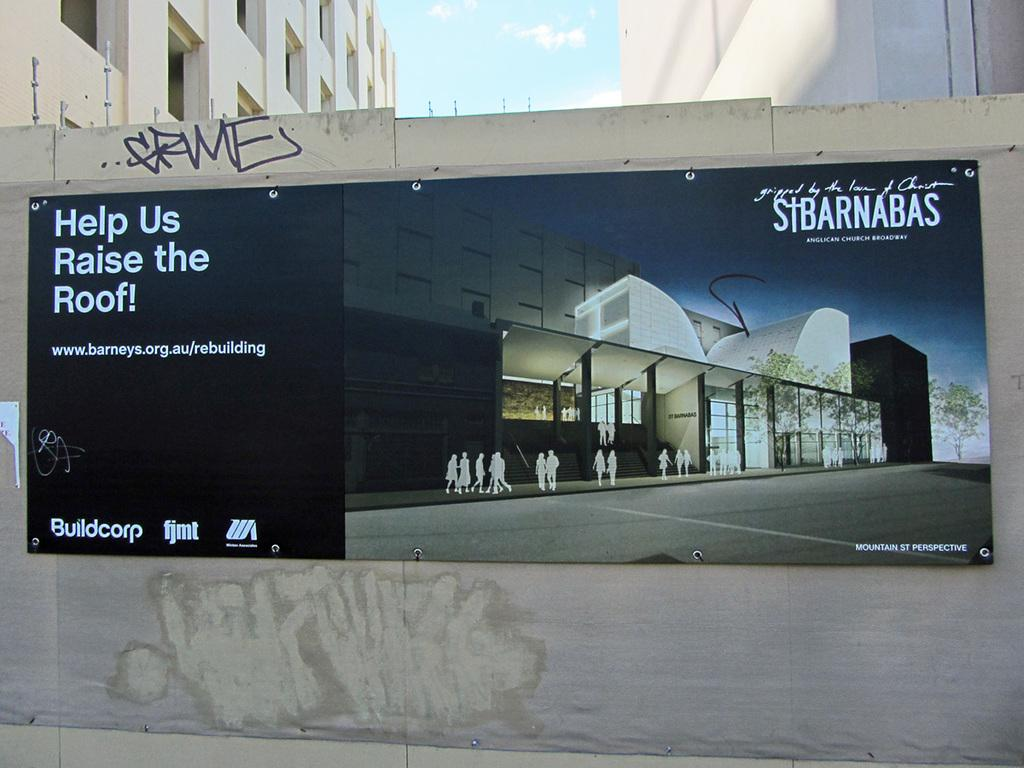Provide a one-sentence caption for the provided image. A St. Barnabas advertisement includes a rallying cry to raise the roof. 